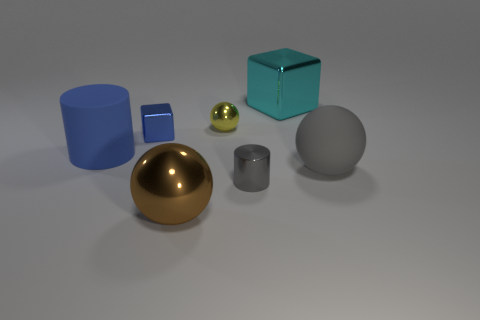If you had to give a name to this composition, what would it be and why? I would call this composition 'Harmony in Geometry.' The arrangement of shapes and colors seems carefully balanced, and there is a pleasing aesthetic symmetry to it. The different geometrical forms – spheres, cylinders, and cubes – are positioned in a way that feels harmonious and intentional, as if each piece has been thoughtfully placed to complement the others. 